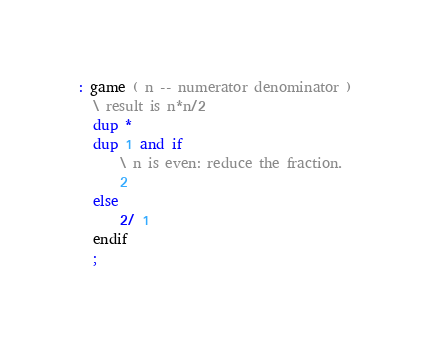Convert code to text. <code><loc_0><loc_0><loc_500><loc_500><_Forth_>: game ( n -- numerator denominator )
  \ result is n*n/2
  dup *
  dup 1 and if
      \ n is even: reduce the fraction.
      2
  else
      2/ 1    
  endif
  ;</code> 